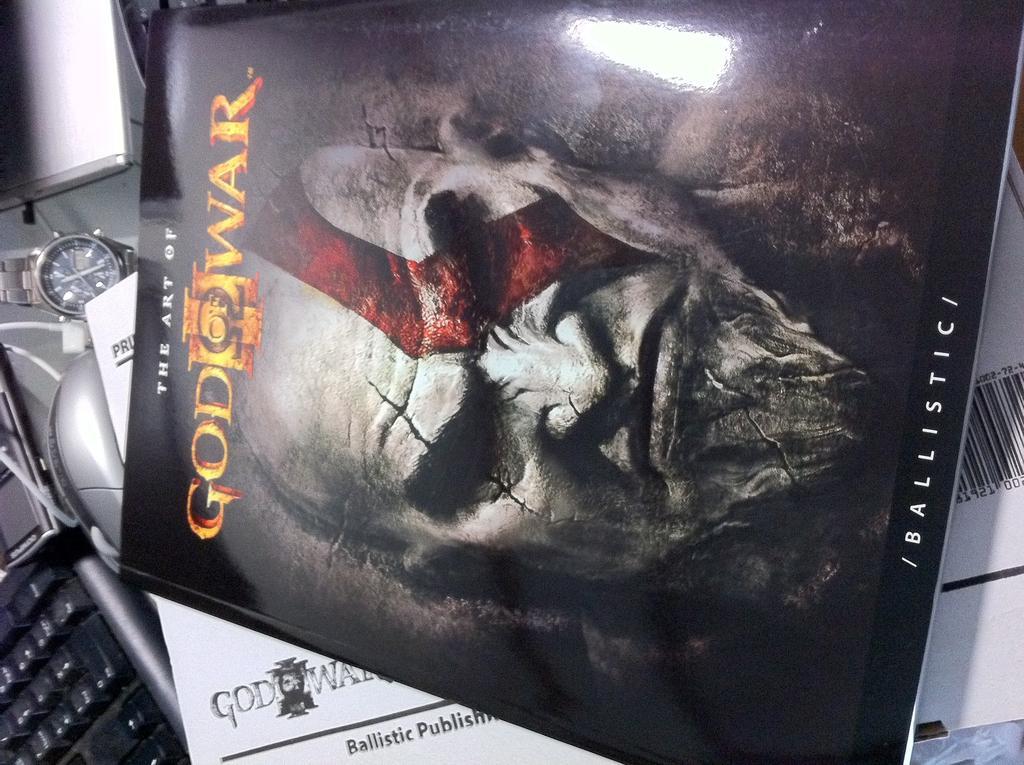Can you describe this image briefly? In the picture we can see a film poster card with the name God war and behind it we can see some paper, keyboard with buttons and beside it we can see wrist watch. 